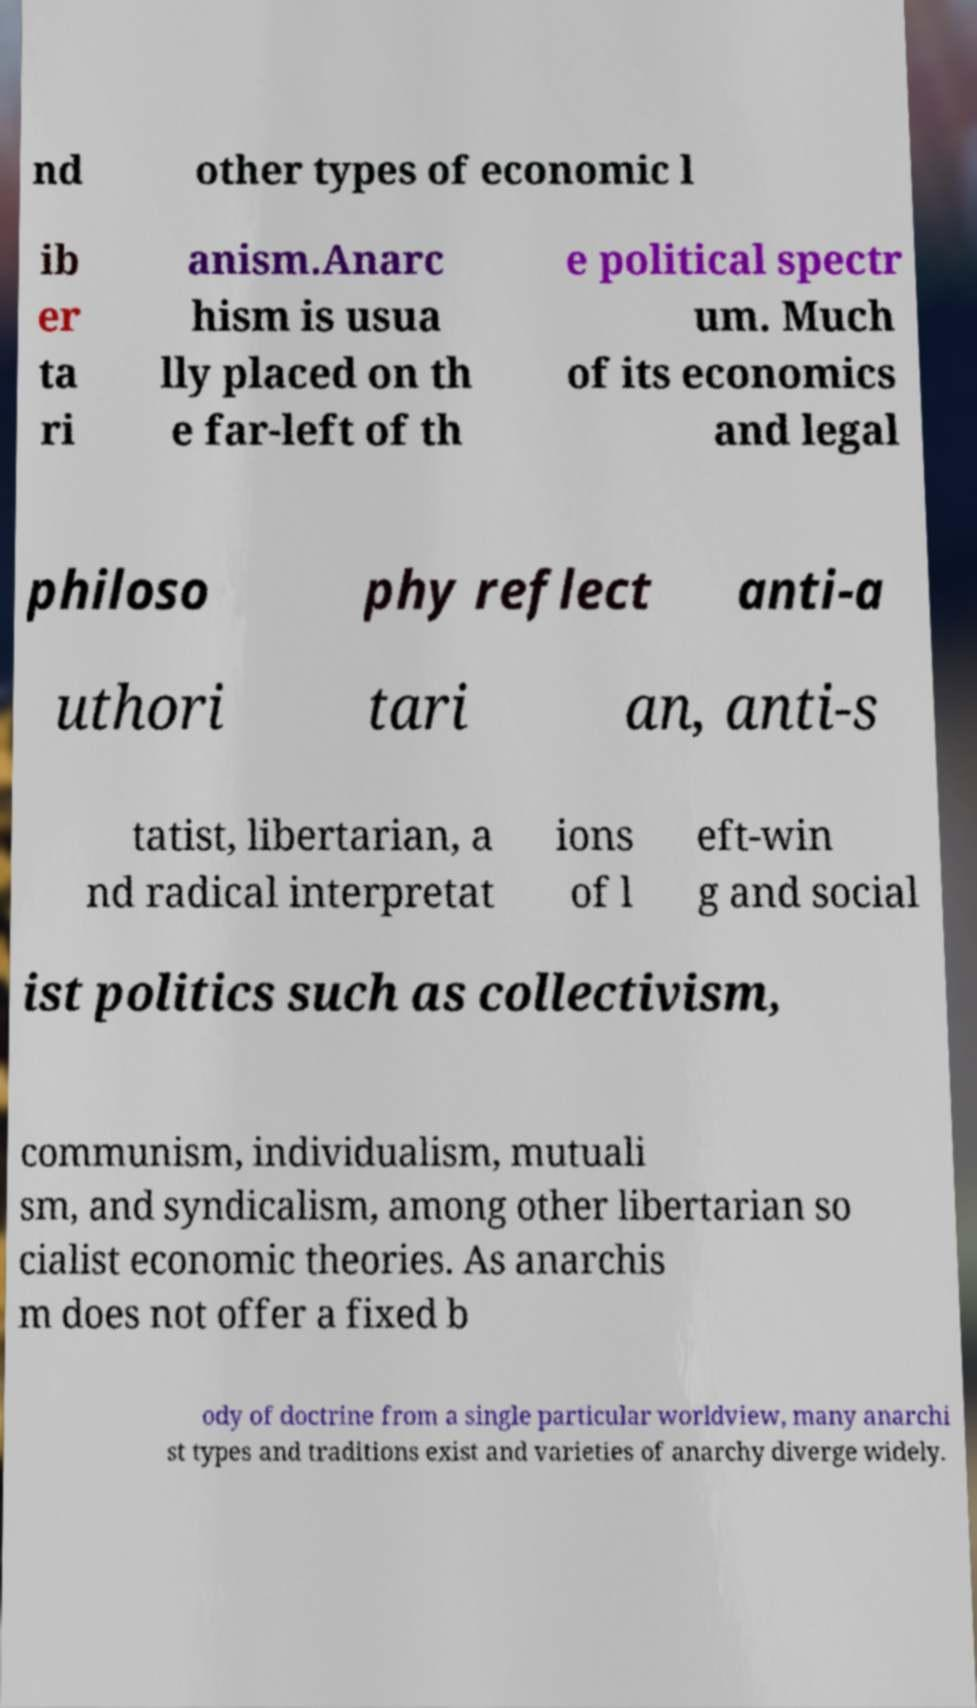Could you extract and type out the text from this image? nd other types of economic l ib er ta ri anism.Anarc hism is usua lly placed on th e far-left of th e political spectr um. Much of its economics and legal philoso phy reflect anti-a uthori tari an, anti-s tatist, libertarian, a nd radical interpretat ions of l eft-win g and social ist politics such as collectivism, communism, individualism, mutuali sm, and syndicalism, among other libertarian so cialist economic theories. As anarchis m does not offer a fixed b ody of doctrine from a single particular worldview, many anarchi st types and traditions exist and varieties of anarchy diverge widely. 